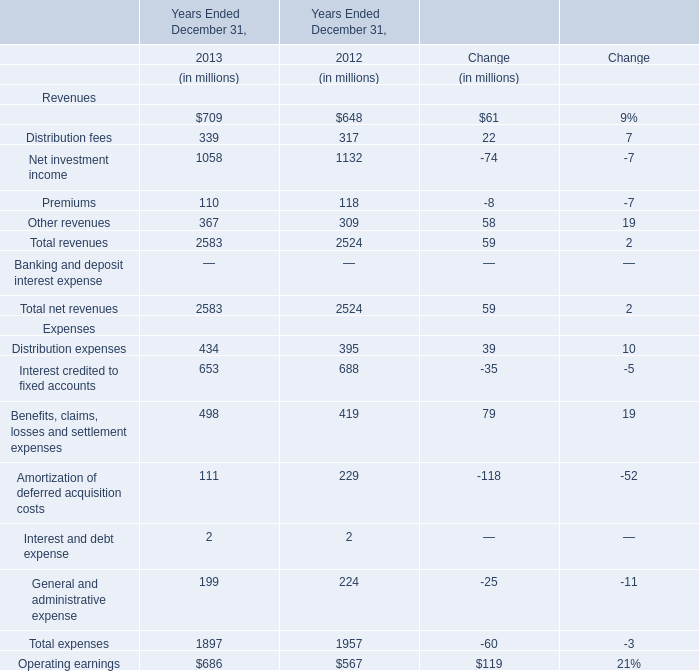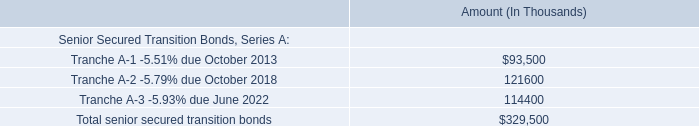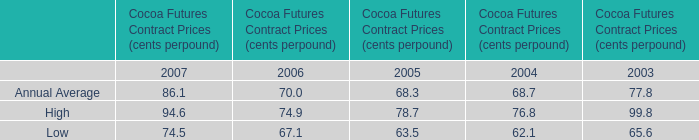In the year with largest amount of Premiums, what's the increasing rate of Other revenues? 
Computations: ((367 - 309) / 309)
Answer: 0.1877. 